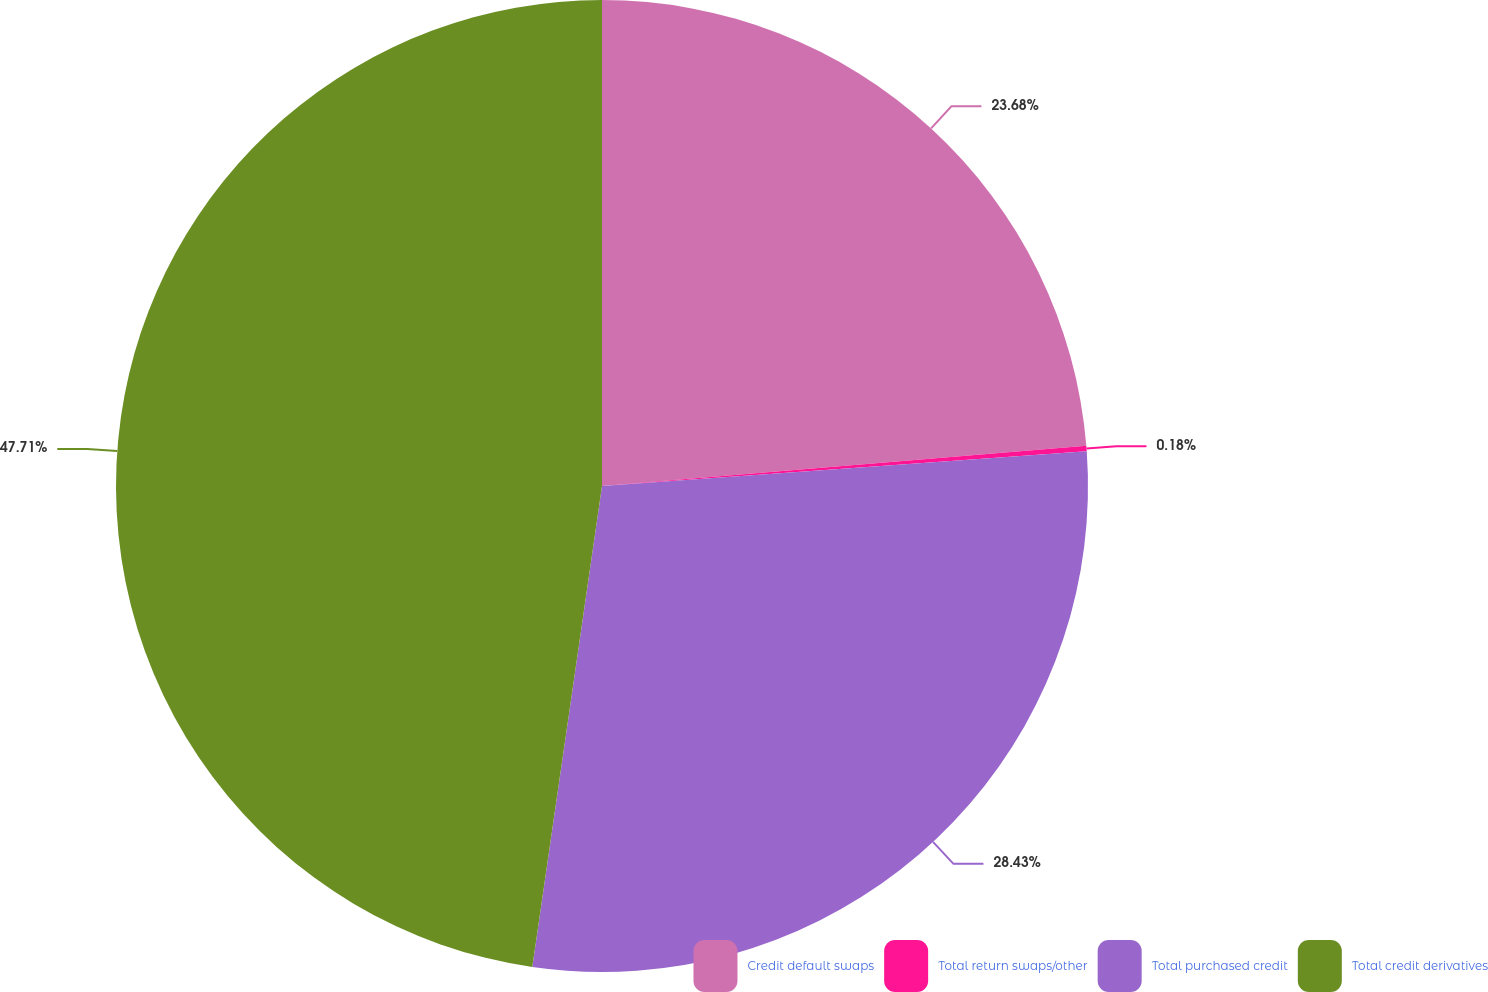Convert chart. <chart><loc_0><loc_0><loc_500><loc_500><pie_chart><fcel>Credit default swaps<fcel>Total return swaps/other<fcel>Total purchased credit<fcel>Total credit derivatives<nl><fcel>23.68%<fcel>0.18%<fcel>28.43%<fcel>47.71%<nl></chart> 